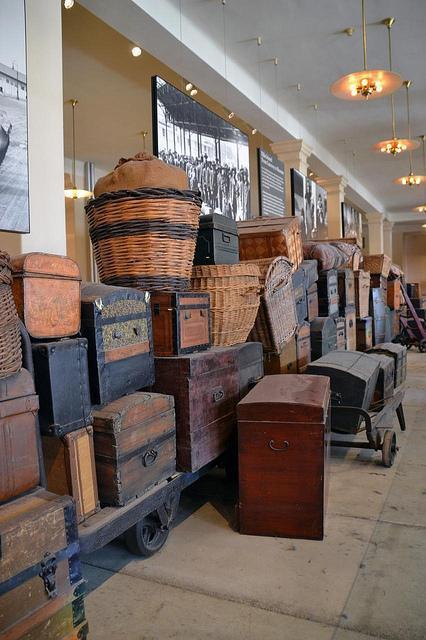How many wicker baskets are in the picture?
Give a very brief answer. 2. How many suitcases can be seen?
Give a very brief answer. 5. 